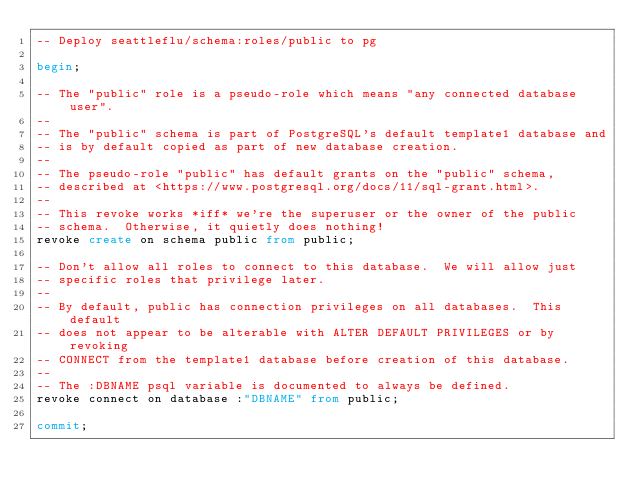Convert code to text. <code><loc_0><loc_0><loc_500><loc_500><_SQL_>-- Deploy seattleflu/schema:roles/public to pg

begin;

-- The "public" role is a pseudo-role which means "any connected database user".
--
-- The "public" schema is part of PostgreSQL's default template1 database and
-- is by default copied as part of new database creation.
--
-- The pseudo-role "public" has default grants on the "public" schema,
-- described at <https://www.postgresql.org/docs/11/sql-grant.html>.
--
-- This revoke works *iff* we're the superuser or the owner of the public
-- schema.  Otherwise, it quietly does nothing!
revoke create on schema public from public;

-- Don't allow all roles to connect to this database.  We will allow just
-- specific roles that privilege later.
--
-- By default, public has connection privileges on all databases.  This default
-- does not appear to be alterable with ALTER DEFAULT PRIVILEGES or by revoking
-- CONNECT from the template1 database before creation of this database.
--
-- The :DBNAME psql variable is documented to always be defined.
revoke connect on database :"DBNAME" from public;

commit;
</code> 